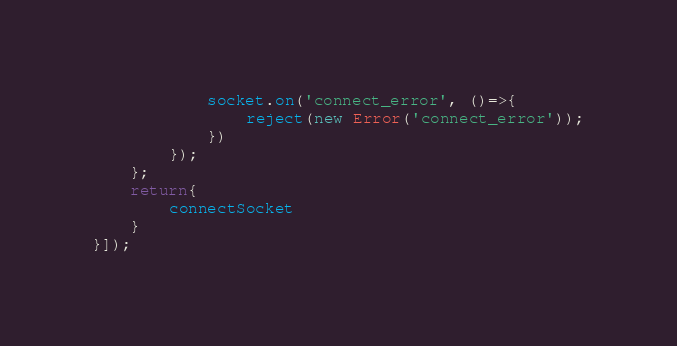Convert code to text. <code><loc_0><loc_0><loc_500><loc_500><_JavaScript_>            socket.on('connect_error', ()=>{
                reject(new Error('connect_error'));
            })
        });
    };
    return{
        connectSocket
    }
}]);</code> 